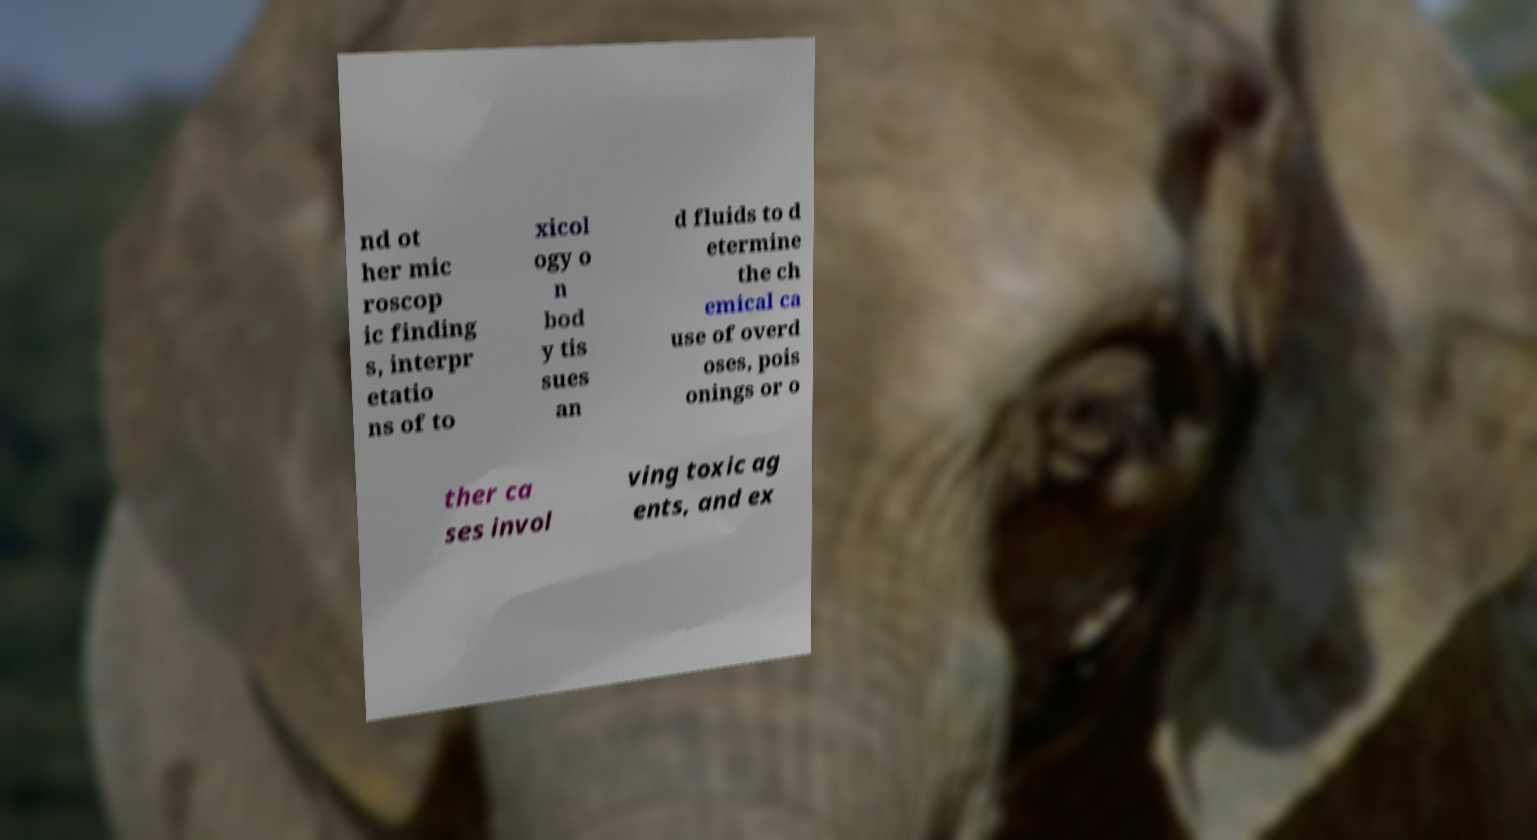There's text embedded in this image that I need extracted. Can you transcribe it verbatim? nd ot her mic roscop ic finding s, interpr etatio ns of to xicol ogy o n bod y tis sues an d fluids to d etermine the ch emical ca use of overd oses, pois onings or o ther ca ses invol ving toxic ag ents, and ex 